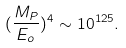<formula> <loc_0><loc_0><loc_500><loc_500>( \frac { M _ { P } } { E _ { o } } ) ^ { 4 } \sim 1 0 ^ { 1 2 5 } .</formula> 